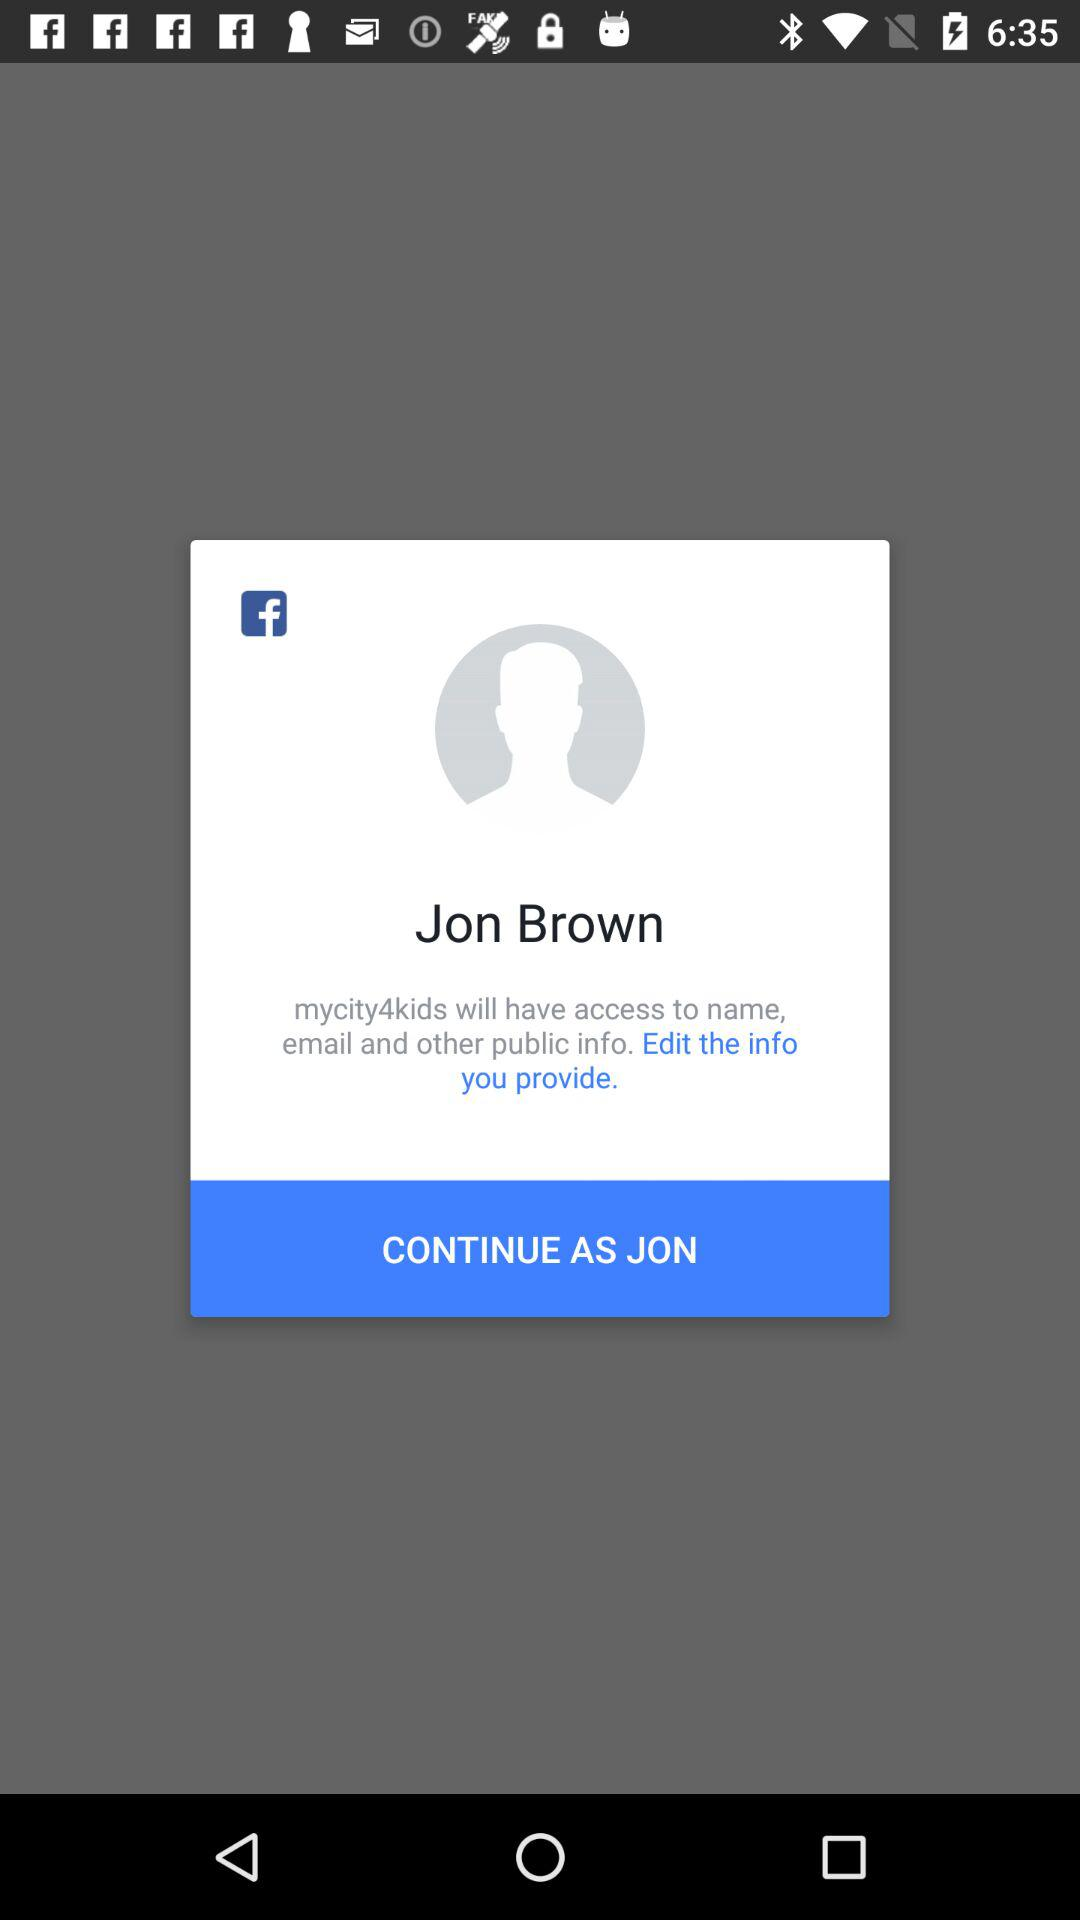What application is used to log in? The application used to log in is "Facebook". 